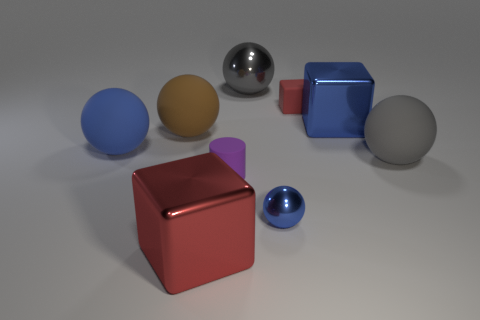There is a red object behind the purple rubber cylinder; is its size the same as the red cube in front of the red matte object?
Give a very brief answer. No. What number of other things are there of the same size as the rubber cylinder?
Provide a short and direct response. 2. There is a tiny purple object that is right of the brown object; what number of red things are to the left of it?
Offer a very short reply. 1. Are there fewer matte things behind the purple rubber cylinder than tiny yellow cubes?
Your answer should be compact. No. What is the shape of the gray object behind the blue metal thing behind the small rubber object on the left side of the large shiny sphere?
Offer a terse response. Sphere. Do the brown matte thing and the big red metallic thing have the same shape?
Ensure brevity in your answer.  No. What number of other things are the same shape as the small metal thing?
Provide a short and direct response. 4. What color is the shiny ball that is the same size as the brown matte ball?
Provide a short and direct response. Gray. Are there the same number of objects behind the red rubber cube and red rubber objects?
Keep it short and to the point. Yes. There is a big matte thing that is both on the right side of the large blue ball and to the left of the gray rubber sphere; what is its shape?
Give a very brief answer. Sphere. 